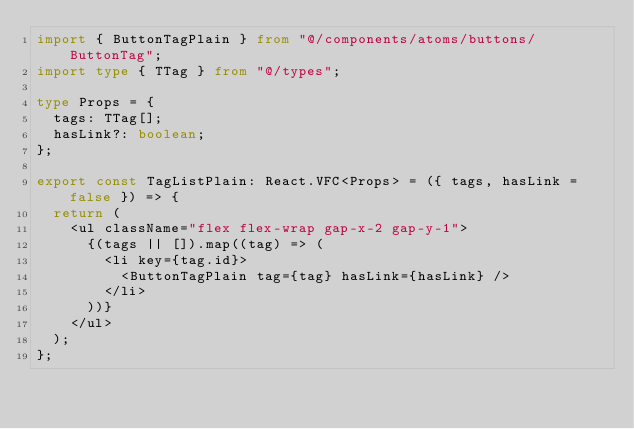<code> <loc_0><loc_0><loc_500><loc_500><_TypeScript_>import { ButtonTagPlain } from "@/components/atoms/buttons/ButtonTag";
import type { TTag } from "@/types";

type Props = {
  tags: TTag[];
  hasLink?: boolean;
};

export const TagListPlain: React.VFC<Props> = ({ tags, hasLink = false }) => {
  return (
    <ul className="flex flex-wrap gap-x-2 gap-y-1">
      {(tags || []).map((tag) => (
        <li key={tag.id}>
          <ButtonTagPlain tag={tag} hasLink={hasLink} />
        </li>
      ))}
    </ul>
  );
};
</code> 